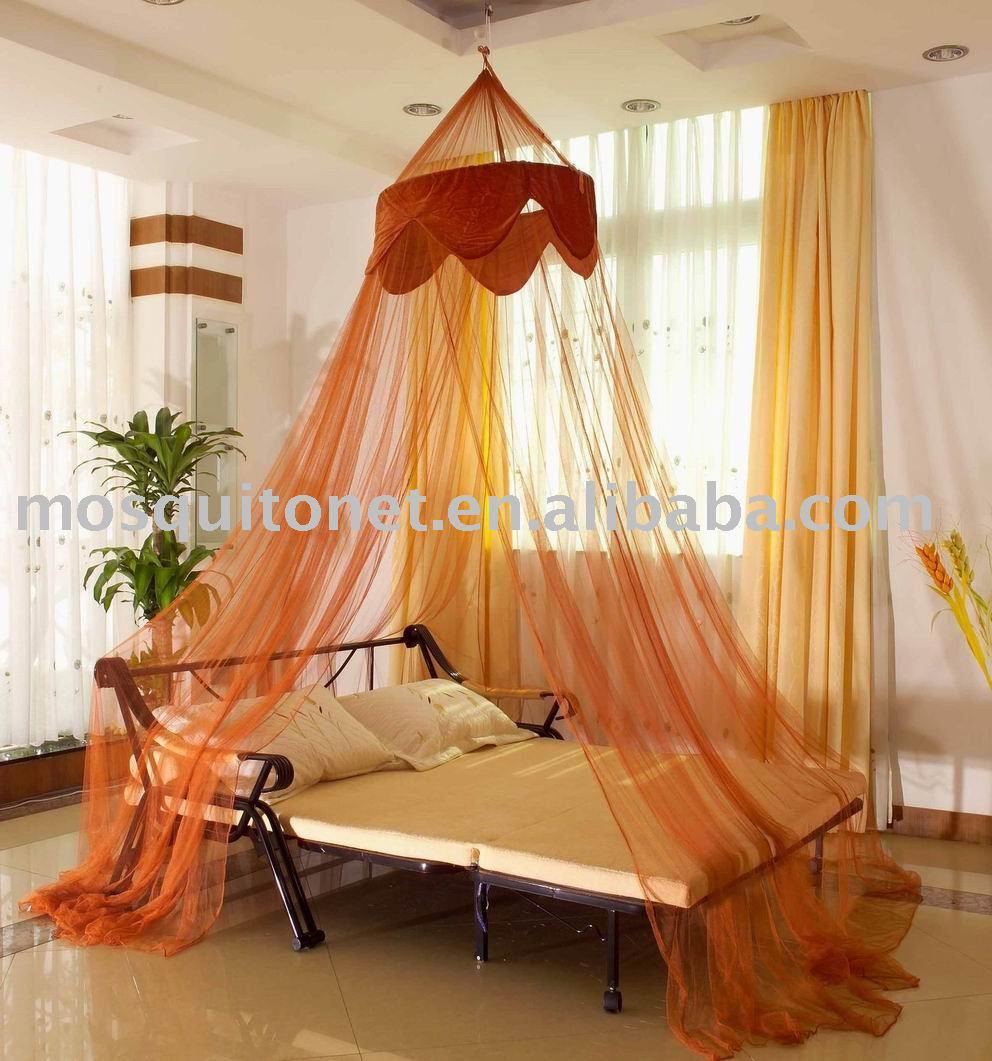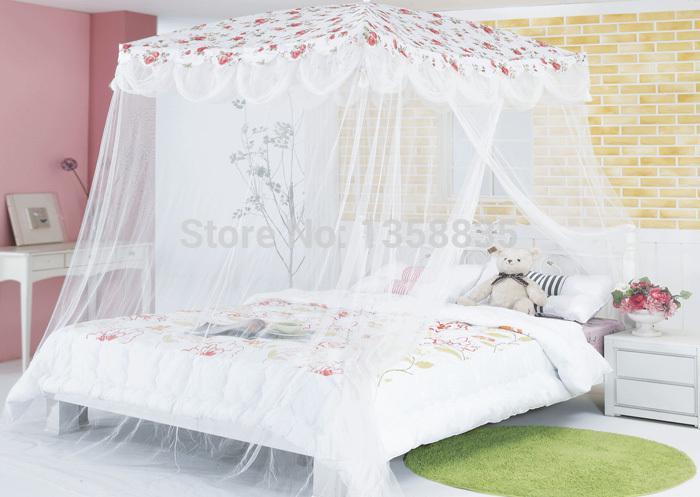The first image is the image on the left, the second image is the image on the right. Considering the images on both sides, is "Two or more lamp shades are visible." valid? Answer yes or no. No. The first image is the image on the left, the second image is the image on the right. Evaluate the accuracy of this statement regarding the images: "Exactly one bed has a round canopy.". Is it true? Answer yes or no. Yes. 